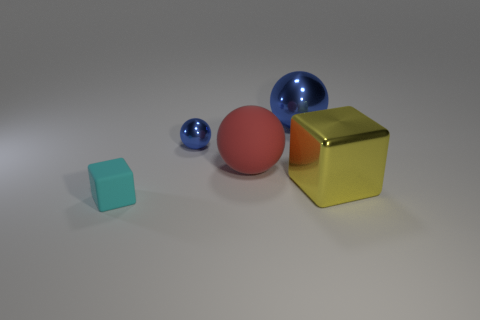Do the ball to the left of the red rubber thing and the large blue object have the same material?
Make the answer very short. Yes. What is the shape of the tiny thing on the right side of the thing in front of the thing right of the large blue shiny sphere?
Give a very brief answer. Sphere. What number of cyan things are either small rubber things or big matte cylinders?
Your answer should be compact. 1. Are there an equal number of objects that are on the left side of the red ball and large spheres on the left side of the cyan thing?
Offer a very short reply. No. There is a large object that is to the right of the big metallic ball; is its shape the same as the small object in front of the large cube?
Provide a short and direct response. Yes. Is there any other thing that has the same shape as the cyan matte object?
Provide a succinct answer. Yes. There is a thing that is made of the same material as the large red ball; what is its shape?
Your response must be concise. Cube. Is the number of metal objects that are left of the large blue shiny object the same as the number of small blue shiny spheres?
Provide a succinct answer. Yes. Is the material of the small thing on the right side of the tiny rubber object the same as the tiny thing in front of the big yellow metallic cube?
Your answer should be compact. No. What is the shape of the blue thing that is behind the small object that is on the right side of the tiny cyan block?
Give a very brief answer. Sphere. 